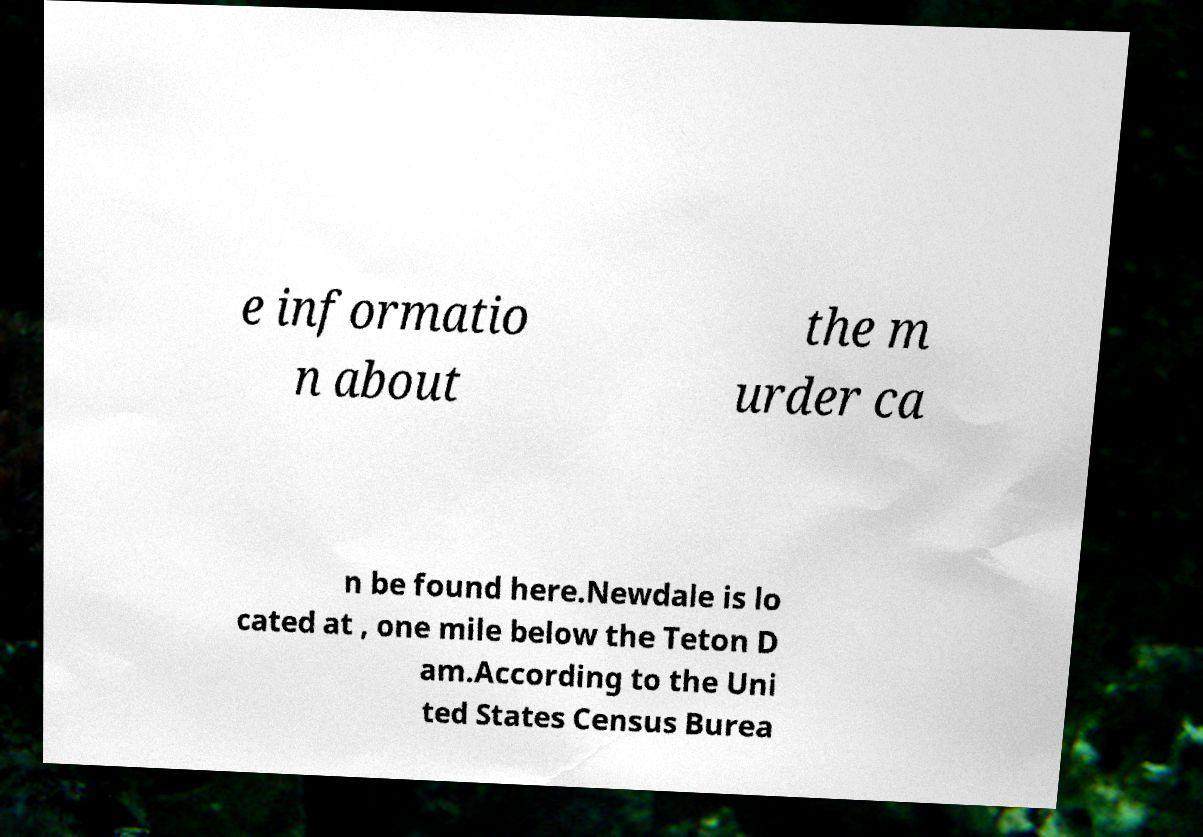Could you assist in decoding the text presented in this image and type it out clearly? e informatio n about the m urder ca n be found here.Newdale is lo cated at , one mile below the Teton D am.According to the Uni ted States Census Burea 